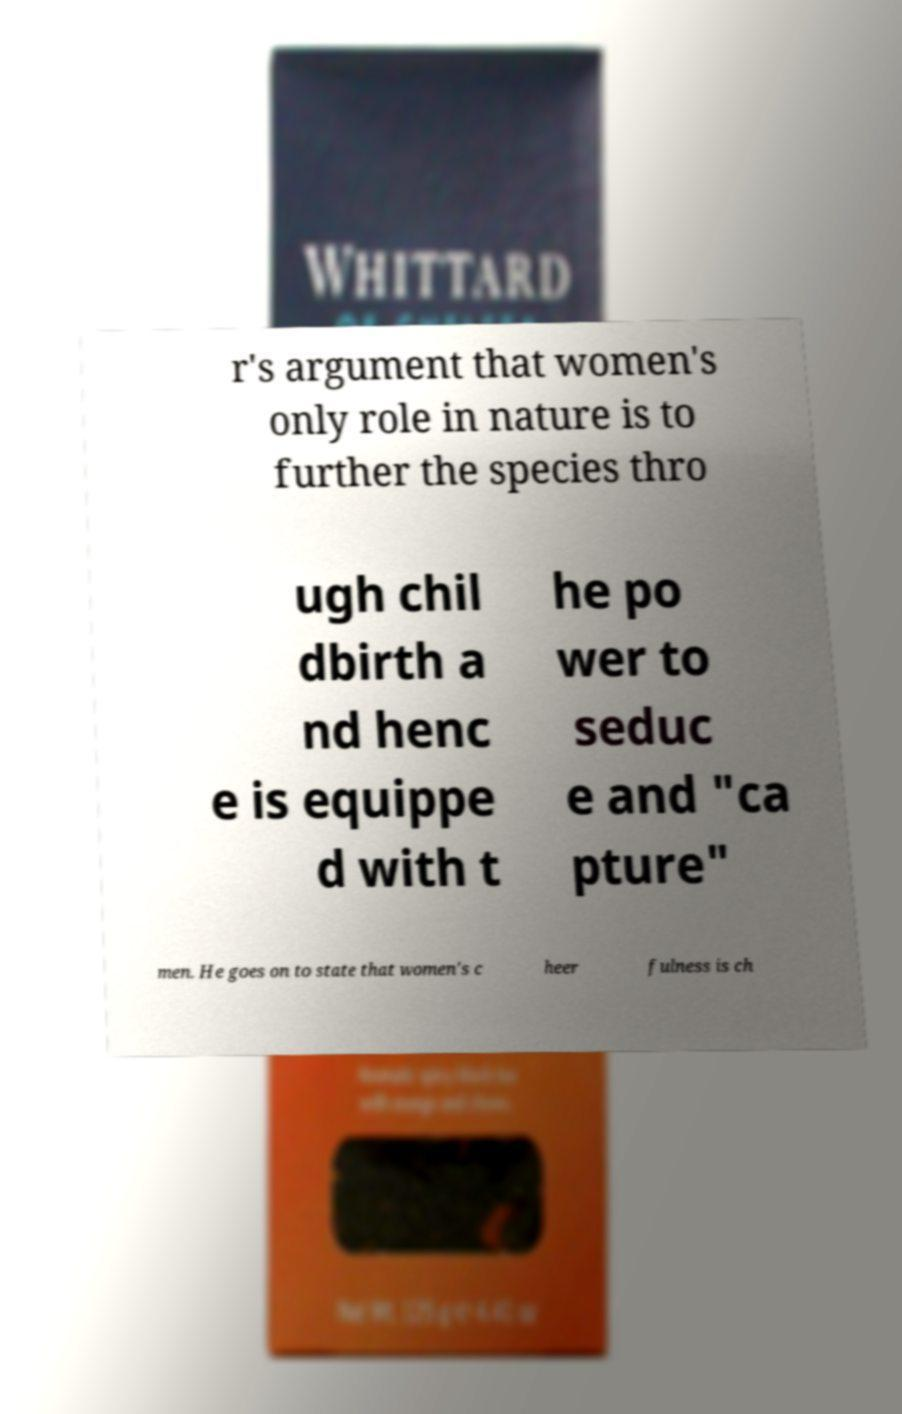Can you read and provide the text displayed in the image?This photo seems to have some interesting text. Can you extract and type it out for me? r's argument that women's only role in nature is to further the species thro ugh chil dbirth a nd henc e is equippe d with t he po wer to seduc e and "ca pture" men. He goes on to state that women's c heer fulness is ch 